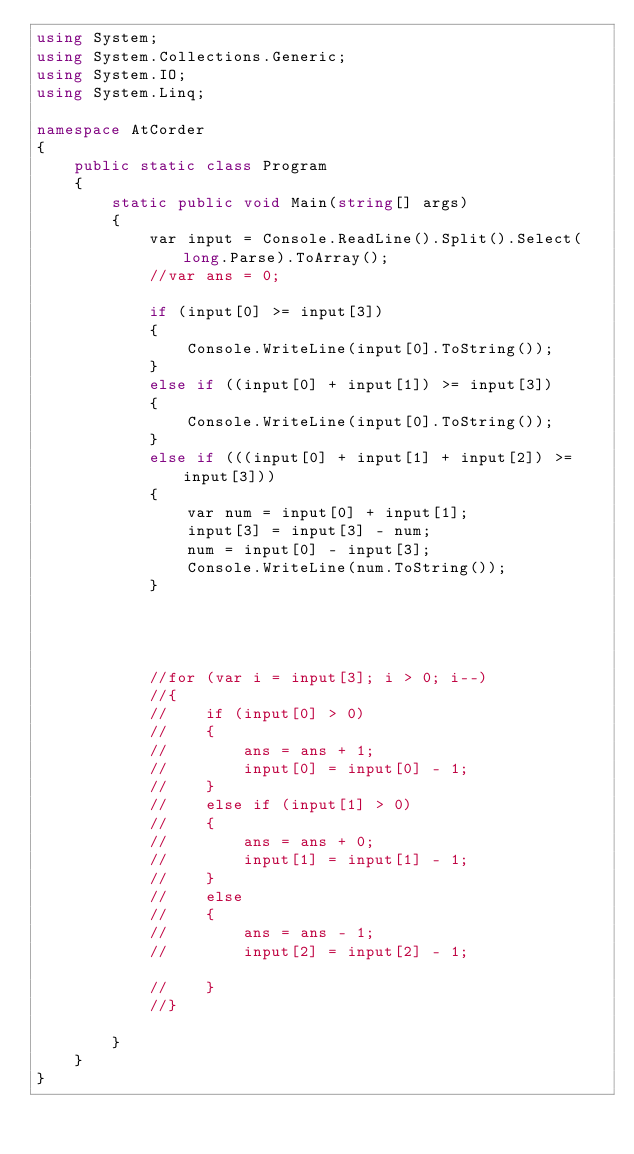<code> <loc_0><loc_0><loc_500><loc_500><_C#_>using System;
using System.Collections.Generic;
using System.IO;
using System.Linq;

namespace AtCorder
{
    public static class Program
    {
        static public void Main(string[] args)
        {
            var input = Console.ReadLine().Split().Select(long.Parse).ToArray();
            //var ans = 0;

            if (input[0] >= input[3])
            {
                Console.WriteLine(input[0].ToString());
            }
            else if ((input[0] + input[1]) >= input[3])
            {
                Console.WriteLine(input[0].ToString());
            }
            else if (((input[0] + input[1] + input[2]) >= input[3]))
            {
                var num = input[0] + input[1];
                input[3] = input[3] - num;
                num = input[0] - input[3];
                Console.WriteLine(num.ToString());
            }




            //for (var i = input[3]; i > 0; i--)
            //{
            //    if (input[0] > 0)
            //    {
            //        ans = ans + 1;
            //        input[0] = input[0] - 1;
            //    }
            //    else if (input[1] > 0)
            //    {
            //        ans = ans + 0;
            //        input[1] = input[1] - 1;
            //    }
            //    else
            //    {
            //        ans = ans - 1;
            //        input[2] = input[2] - 1;

            //    }
            //}

        }
    }
}


</code> 